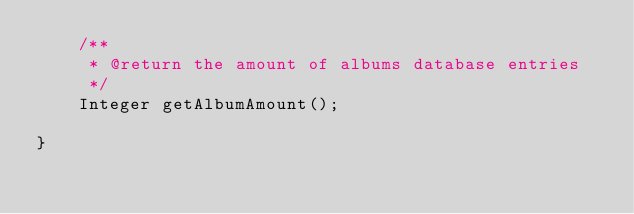<code> <loc_0><loc_0><loc_500><loc_500><_Java_>    /**
     * @return the amount of albums database entries
     */
    Integer getAlbumAmount();

}</code> 